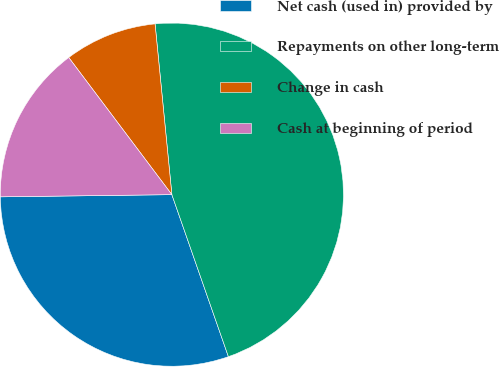Convert chart to OTSL. <chart><loc_0><loc_0><loc_500><loc_500><pie_chart><fcel>Net cash (used in) provided by<fcel>Repayments on other long-term<fcel>Change in cash<fcel>Cash at beginning of period<nl><fcel>30.14%<fcel>46.22%<fcel>8.7%<fcel>14.94%<nl></chart> 